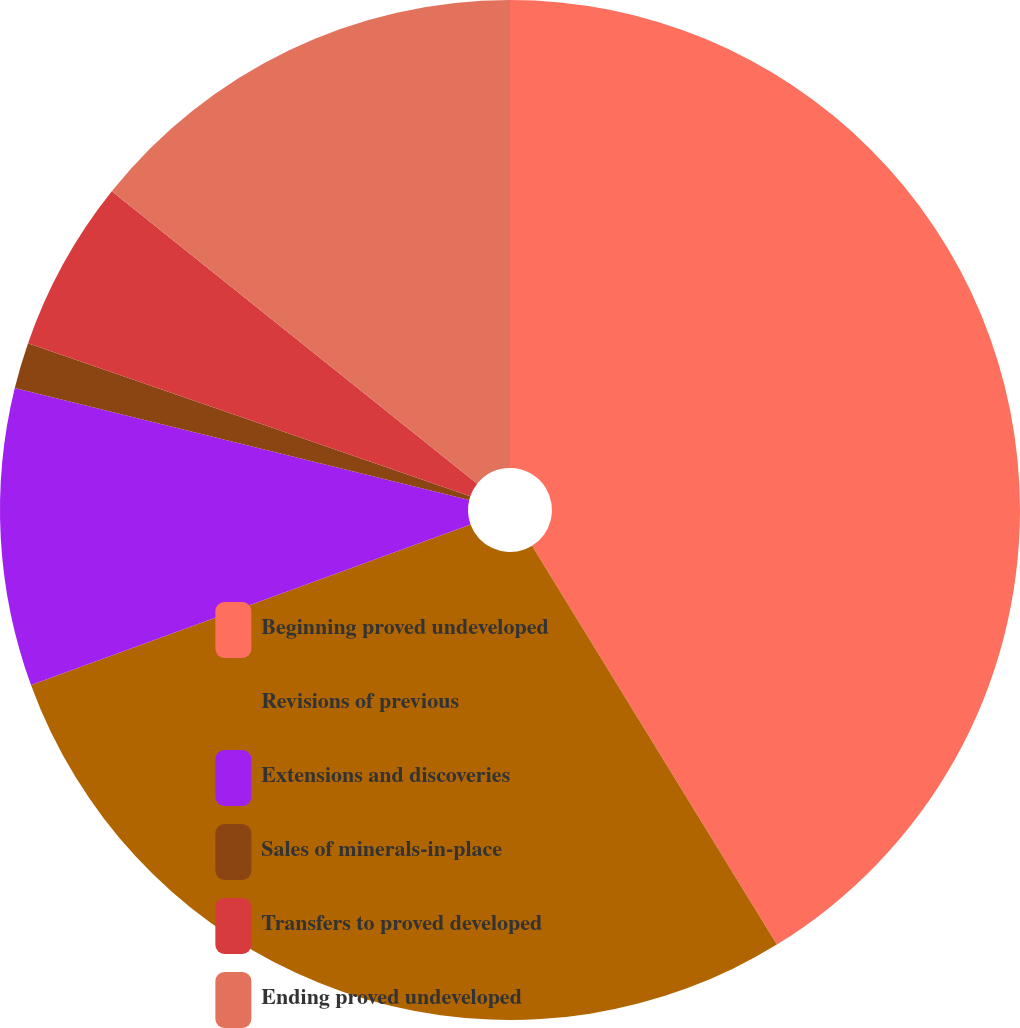<chart> <loc_0><loc_0><loc_500><loc_500><pie_chart><fcel>Beginning proved undeveloped<fcel>Revisions of previous<fcel>Extensions and discoveries<fcel>Sales of minerals-in-place<fcel>Transfers to proved developed<fcel>Ending proved undeveloped<nl><fcel>41.24%<fcel>28.19%<fcel>9.42%<fcel>1.46%<fcel>5.44%<fcel>14.26%<nl></chart> 